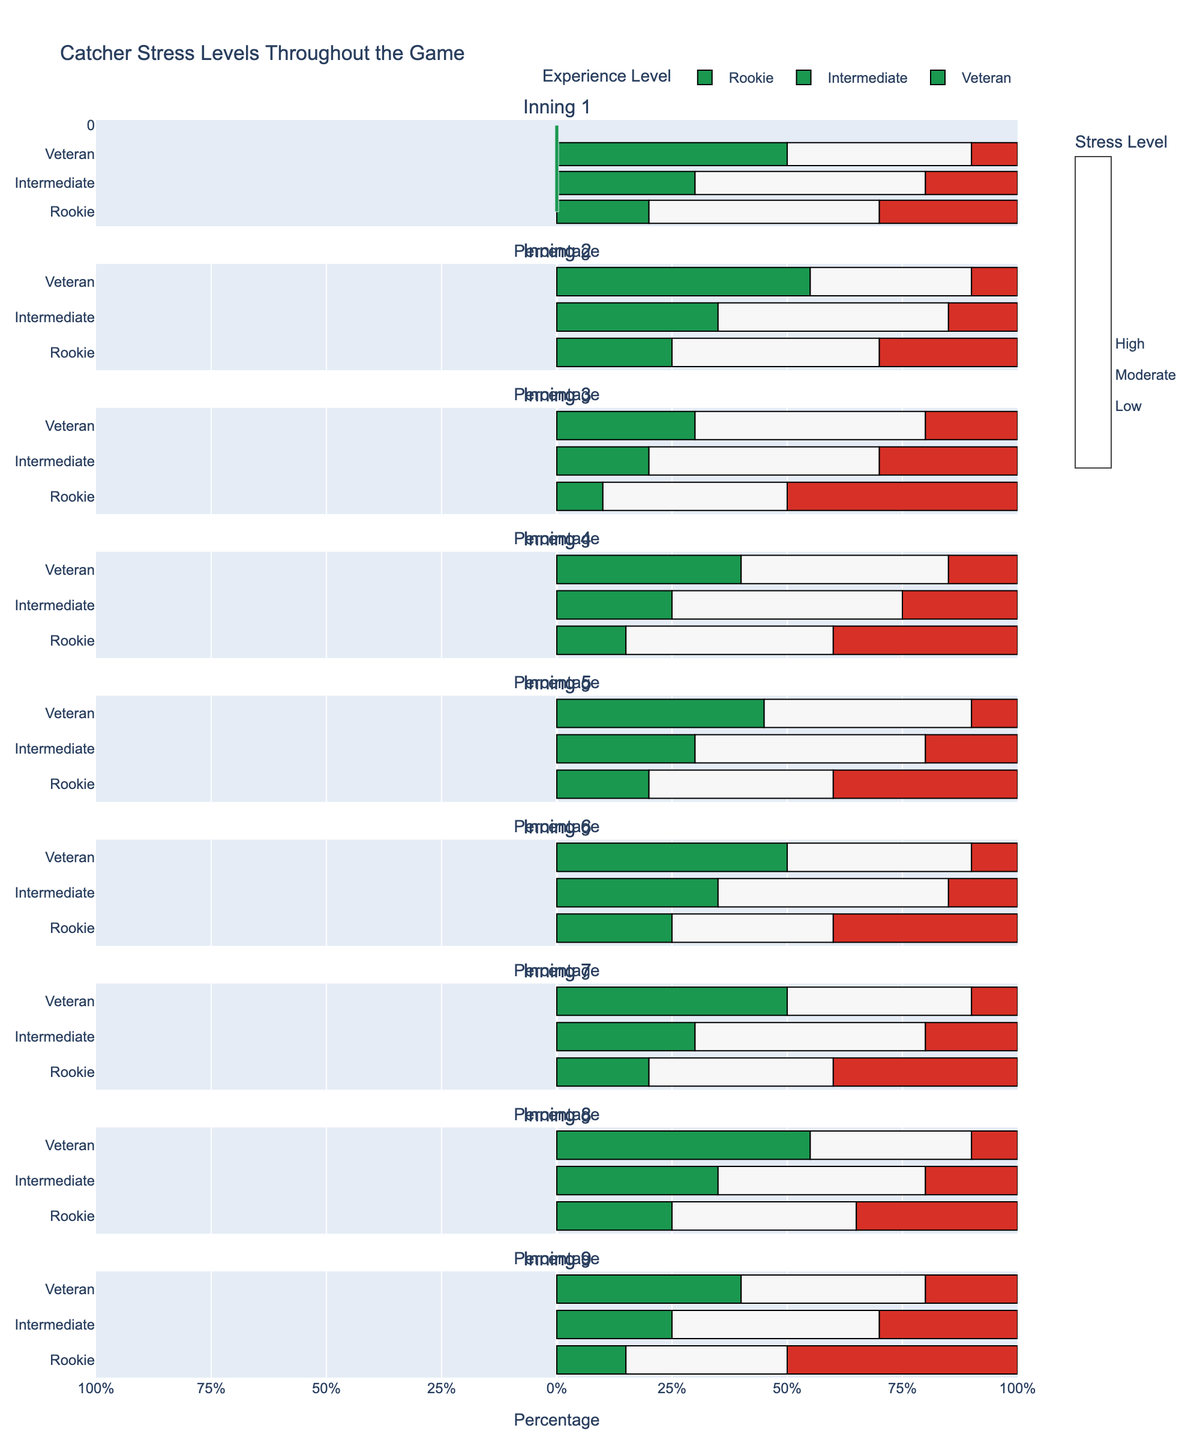Which inning shows the highest percentage of high stress for rookie catchers? In the figure, look for the inning where the red bar (representing high stress) for rookie catchers is the longest. This occurs in inning 9.
Answer: 9 Which experience level showed the lowest percentage of low stress during inning 3? In the figure, compare the green bars (representing low stress) for each experience level during inning 3. The rookie catchers show the shortest green bar (10%).
Answer: Rookie During which inning did veteran catchers have the highest percentage of low stress? Examine the green bars for veteran catchers across all innings and identify where the bar is the longest. This occurs in inning 8 (55%).
Answer: 8 Compare the percentage of moderate stress between rookie and veteran catchers in inning 5. Which group experienced more moderate stress? In inning 5, observe the white bars (representing moderate stress) for both rookie and veteran catchers. Rookie catchers have a shorter white bar (40%) compared to veteran catchers (45%).
Answer: Veteran What is the sum of high stress percentages experienced by intermediate catchers in innings 4 and 9? Find the red bars for intermediate catchers in innings 4 and 9, which are 25% and 30% respectively. Sum these values: 25% + 30% = 55%.
Answer: 55% During which inning did intermediate catchers experience an equal percentage of low and high stress? Check each inning to see where the green and red bars for intermediate catchers are equal. In inning 6, both bars are 35% and 15% respectively, not equal. No inning matches this criterion.
Answer: None Which inning shows the most balanced distribution of stress levels (low, moderate, high) for veteran catchers? Examine the innings where the green, white, and red bars for veteran catchers are closest in length. In inning 9, the bars are 40%, 40%, and 20%, respectively.
Answer: 9 What is the difference in high stress levels between rookie and veteran catchers in inning 1? Calculate the difference between the red bars for rookie and veteran catchers in inning 1. Rookie: 30%, Veteran: 10%. The difference is 30% - 10% = 20%.
Answer: 20% Which inning displayed the lowest percentage of moderate stress for any experience level? Identify the inning where the white bar (moderate stress) is shortest for all experience levels. Inning 9 for rookie catchers shows the shortest white bar at 35%.
Answer: 9 for rookies How does the moderate stress level of intermediate catchers change from inning 1 to inning 7? Compare the white bars for intermediate catchers in innings 1 and 7. In both innings, the percentage remains the same: 50%.
Answer: No change 